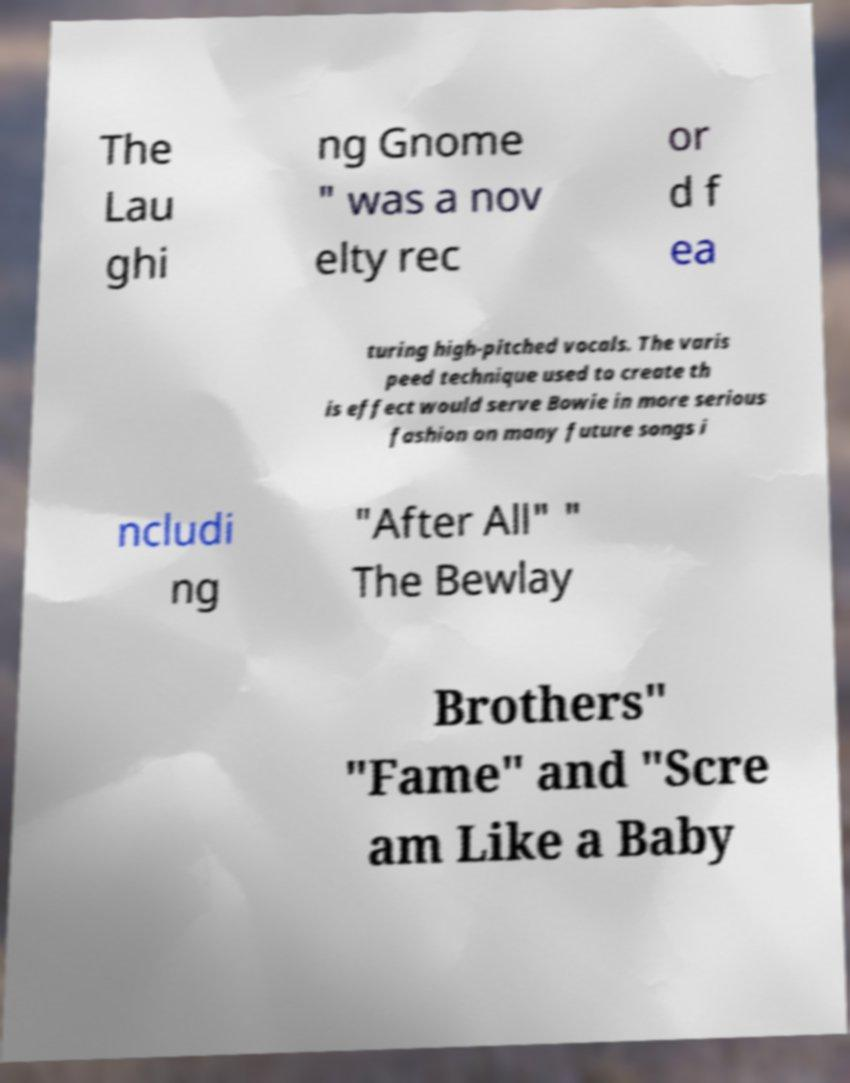Could you assist in decoding the text presented in this image and type it out clearly? The Lau ghi ng Gnome " was a nov elty rec or d f ea turing high-pitched vocals. The varis peed technique used to create th is effect would serve Bowie in more serious fashion on many future songs i ncludi ng "After All" " The Bewlay Brothers" "Fame" and "Scre am Like a Baby 